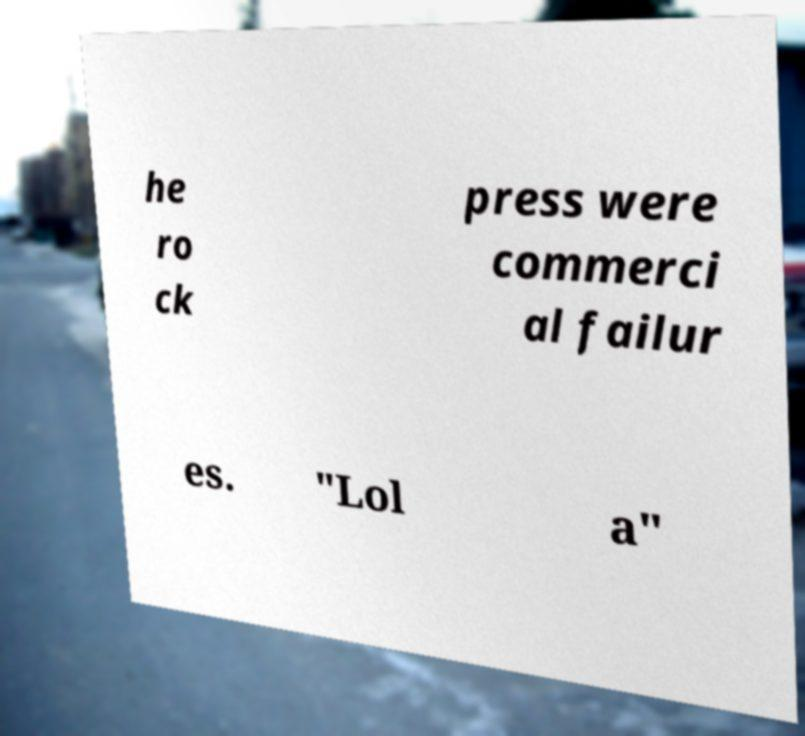Please read and relay the text visible in this image. What does it say? he ro ck press were commerci al failur es. "Lol a" 